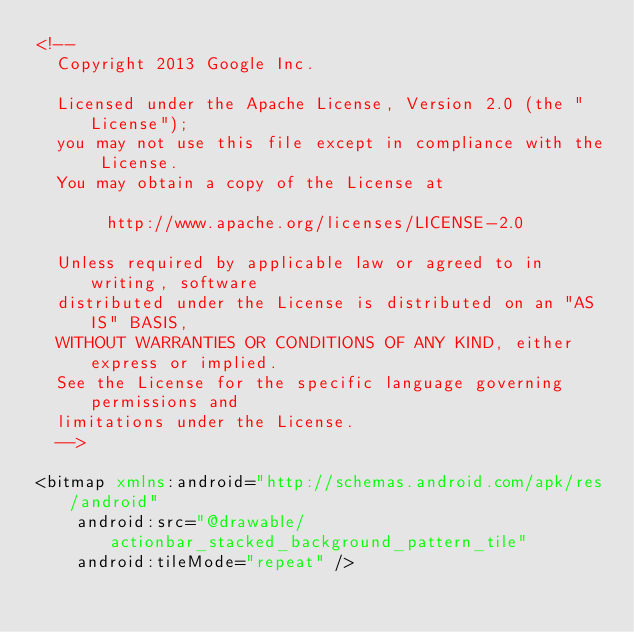Convert code to text. <code><loc_0><loc_0><loc_500><loc_500><_XML_><!--
  Copyright 2013 Google Inc.

  Licensed under the Apache License, Version 2.0 (the "License");
  you may not use this file except in compliance with the License.
  You may obtain a copy of the License at

       http://www.apache.org/licenses/LICENSE-2.0

  Unless required by applicable law or agreed to in writing, software
  distributed under the License is distributed on an "AS IS" BASIS,
  WITHOUT WARRANTIES OR CONDITIONS OF ANY KIND, either express or implied.
  See the License for the specific language governing permissions and
  limitations under the License.
  -->

<bitmap xmlns:android="http://schemas.android.com/apk/res/android"
    android:src="@drawable/actionbar_stacked_background_pattern_tile"
    android:tileMode="repeat" />
</code> 